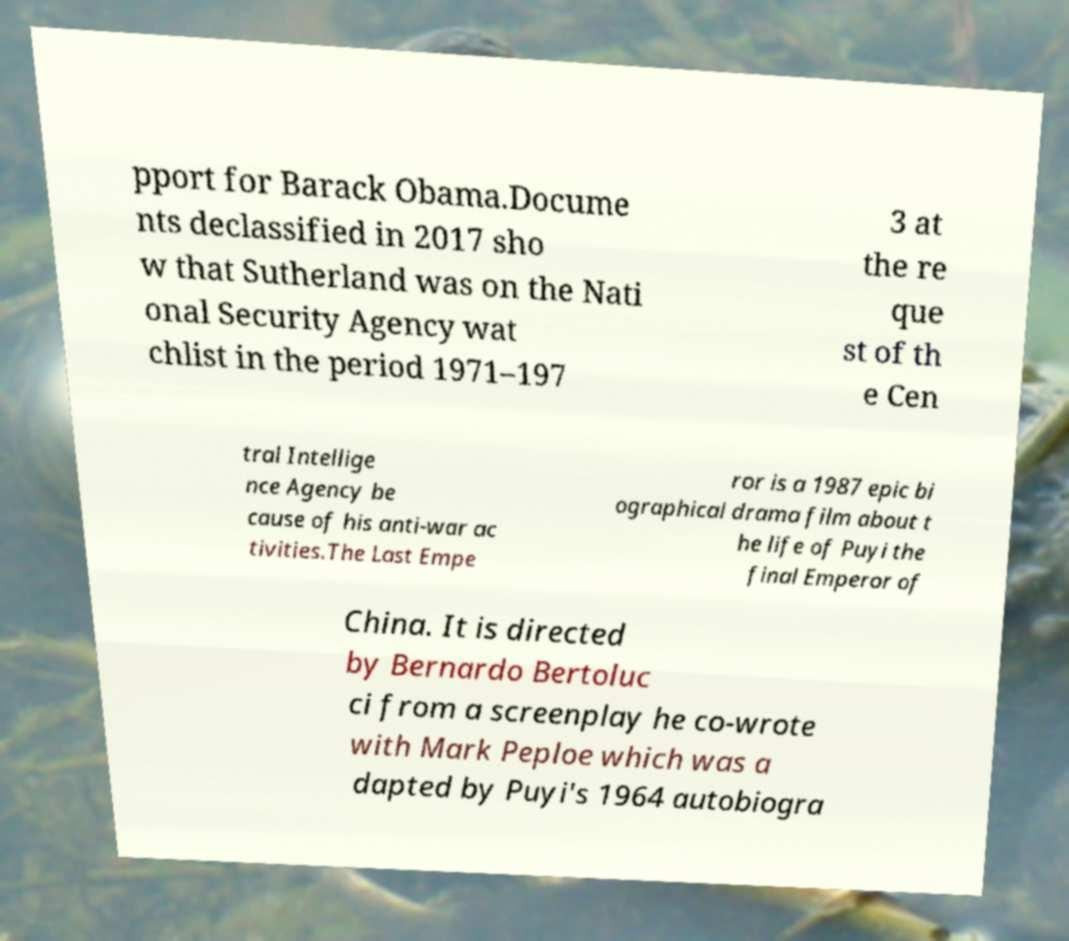Please identify and transcribe the text found in this image. pport for Barack Obama.Docume nts declassified in 2017 sho w that Sutherland was on the Nati onal Security Agency wat chlist in the period 1971–197 3 at the re que st of th e Cen tral Intellige nce Agency be cause of his anti-war ac tivities.The Last Empe ror is a 1987 epic bi ographical drama film about t he life of Puyi the final Emperor of China. It is directed by Bernardo Bertoluc ci from a screenplay he co-wrote with Mark Peploe which was a dapted by Puyi's 1964 autobiogra 